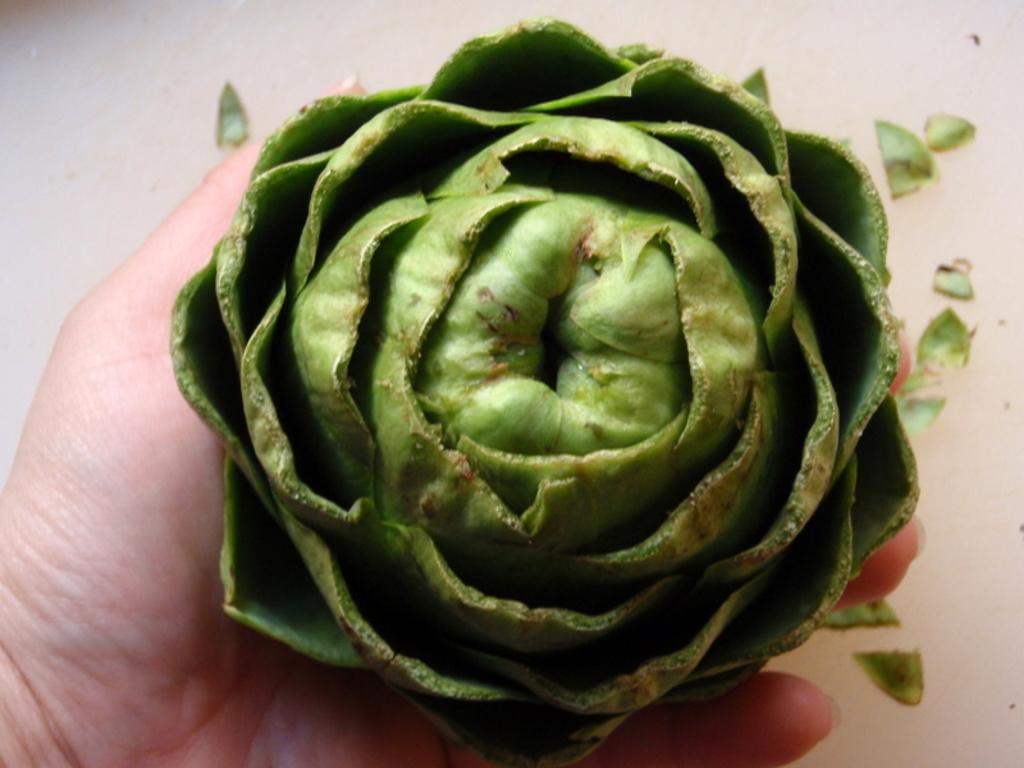Please provide a concise description of this image. In this image I can see hand of a person and on it I can see a green colour thing. I can also see few more green colour things in the background. 